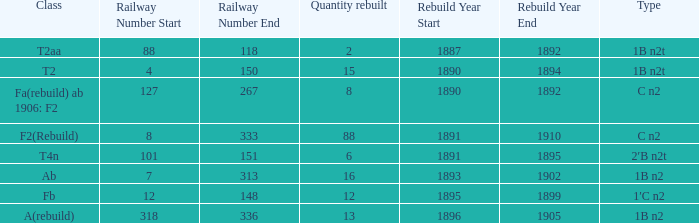What is the type if quantity rebuilt is more than 2 and the railway number is 4"…150? 1B n2t. 